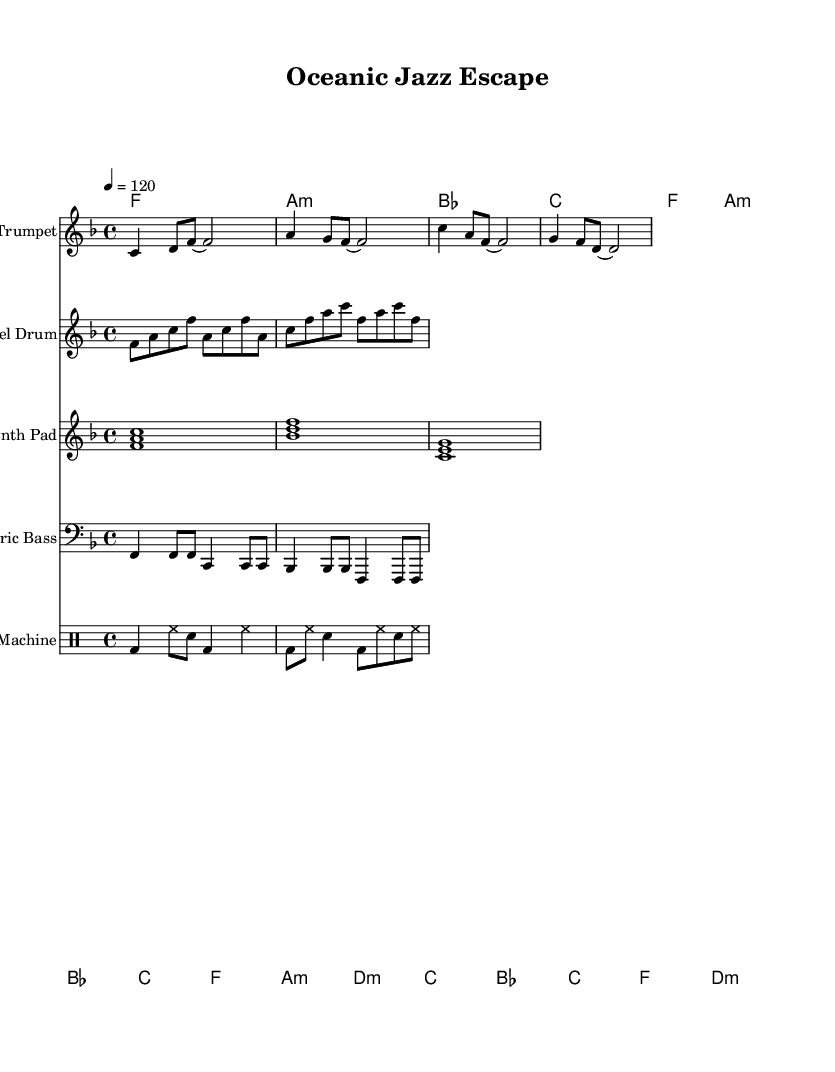What is the key signature of this music? The key signature shown is F major, which has one flat note, B flat. This can be confirmed by the key signature indication at the beginning of the staff.
Answer: F major What is the time signature of this music? The time signature is indicated at the beginning of the score as 4/4. This means there are four beats per measure and a quarter note gets one beat.
Answer: 4/4 What is the tempo marking given for this piece? The tempo marking indicates that the piece should be played at a speed of 120 beats per minute. This is visible in the tempo indication at the beginning.
Answer: 120 How many measures are in the trumpet part? Counting the measures in the trumpet part shows there are a total of four measures in the provided section, as indicated by the vertical lines separating the different sections.
Answer: 4 Which instrument has a staff labeled as "Drum Machine"? The score explicitly labels one of the staves as "Drum Machine," which is a common component in house music for rhythm purposes.
Answer: Drum Machine What chords are used in the chord progression? The chords in the chord progression listed are F, A minor, B flat, C, and D minor, as seen in the chord names provided in the ChordNames section of the score.
Answer: F, A minor, B flat, C, D minor Which rhythmic elements are established by the drum machine? The drum machine includes a kick drum (bd), hi-hat (hh), and snare (sn), creating a typical groove pattern essential in electronic and house music.
Answer: Kick drum, hi-hat, snare 